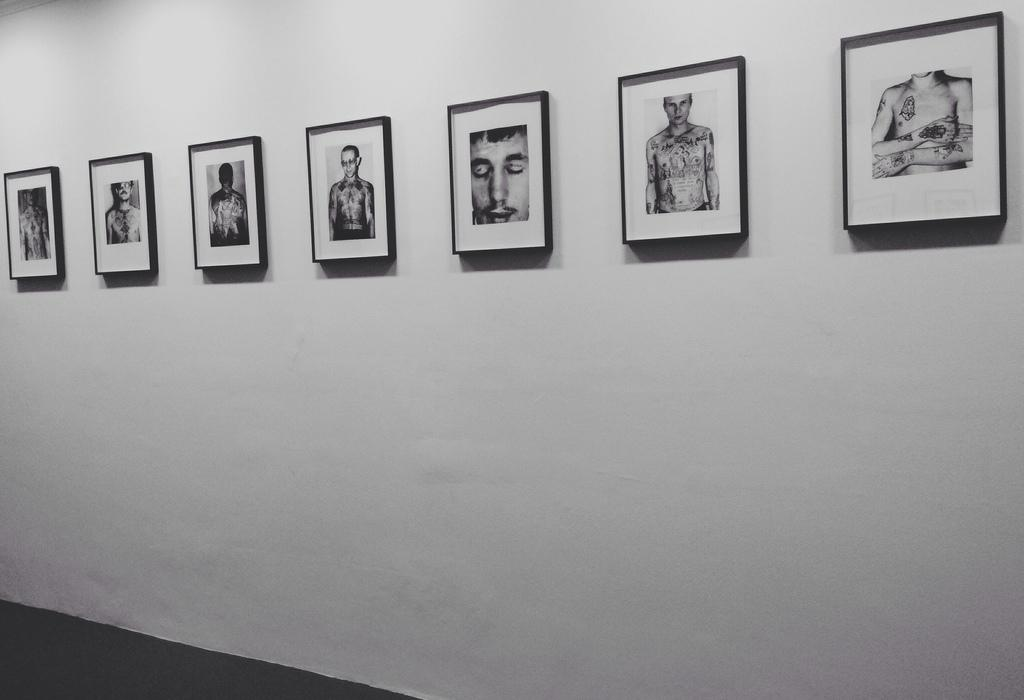What objects are present in the image? There are photo frames in the image. Where are the photo frames located? The photo frames are attached to a white color wall. How are the photo frames positioned in the image? The photo frames are in the middle of the image. What type of car is parked in front of the wall in the image? There is no car present in the image; it only features photo frames attached to a white color wall. 